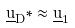<formula> <loc_0><loc_0><loc_500><loc_500>\underline { u } _ { D } * \approx \underline { u } _ { 1 }</formula> 